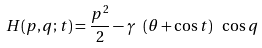Convert formula to latex. <formula><loc_0><loc_0><loc_500><loc_500>H ( p , q ; t ) = \frac { p ^ { 2 } } { 2 } - \gamma \ ( \theta + \cos t ) \ \cos q</formula> 